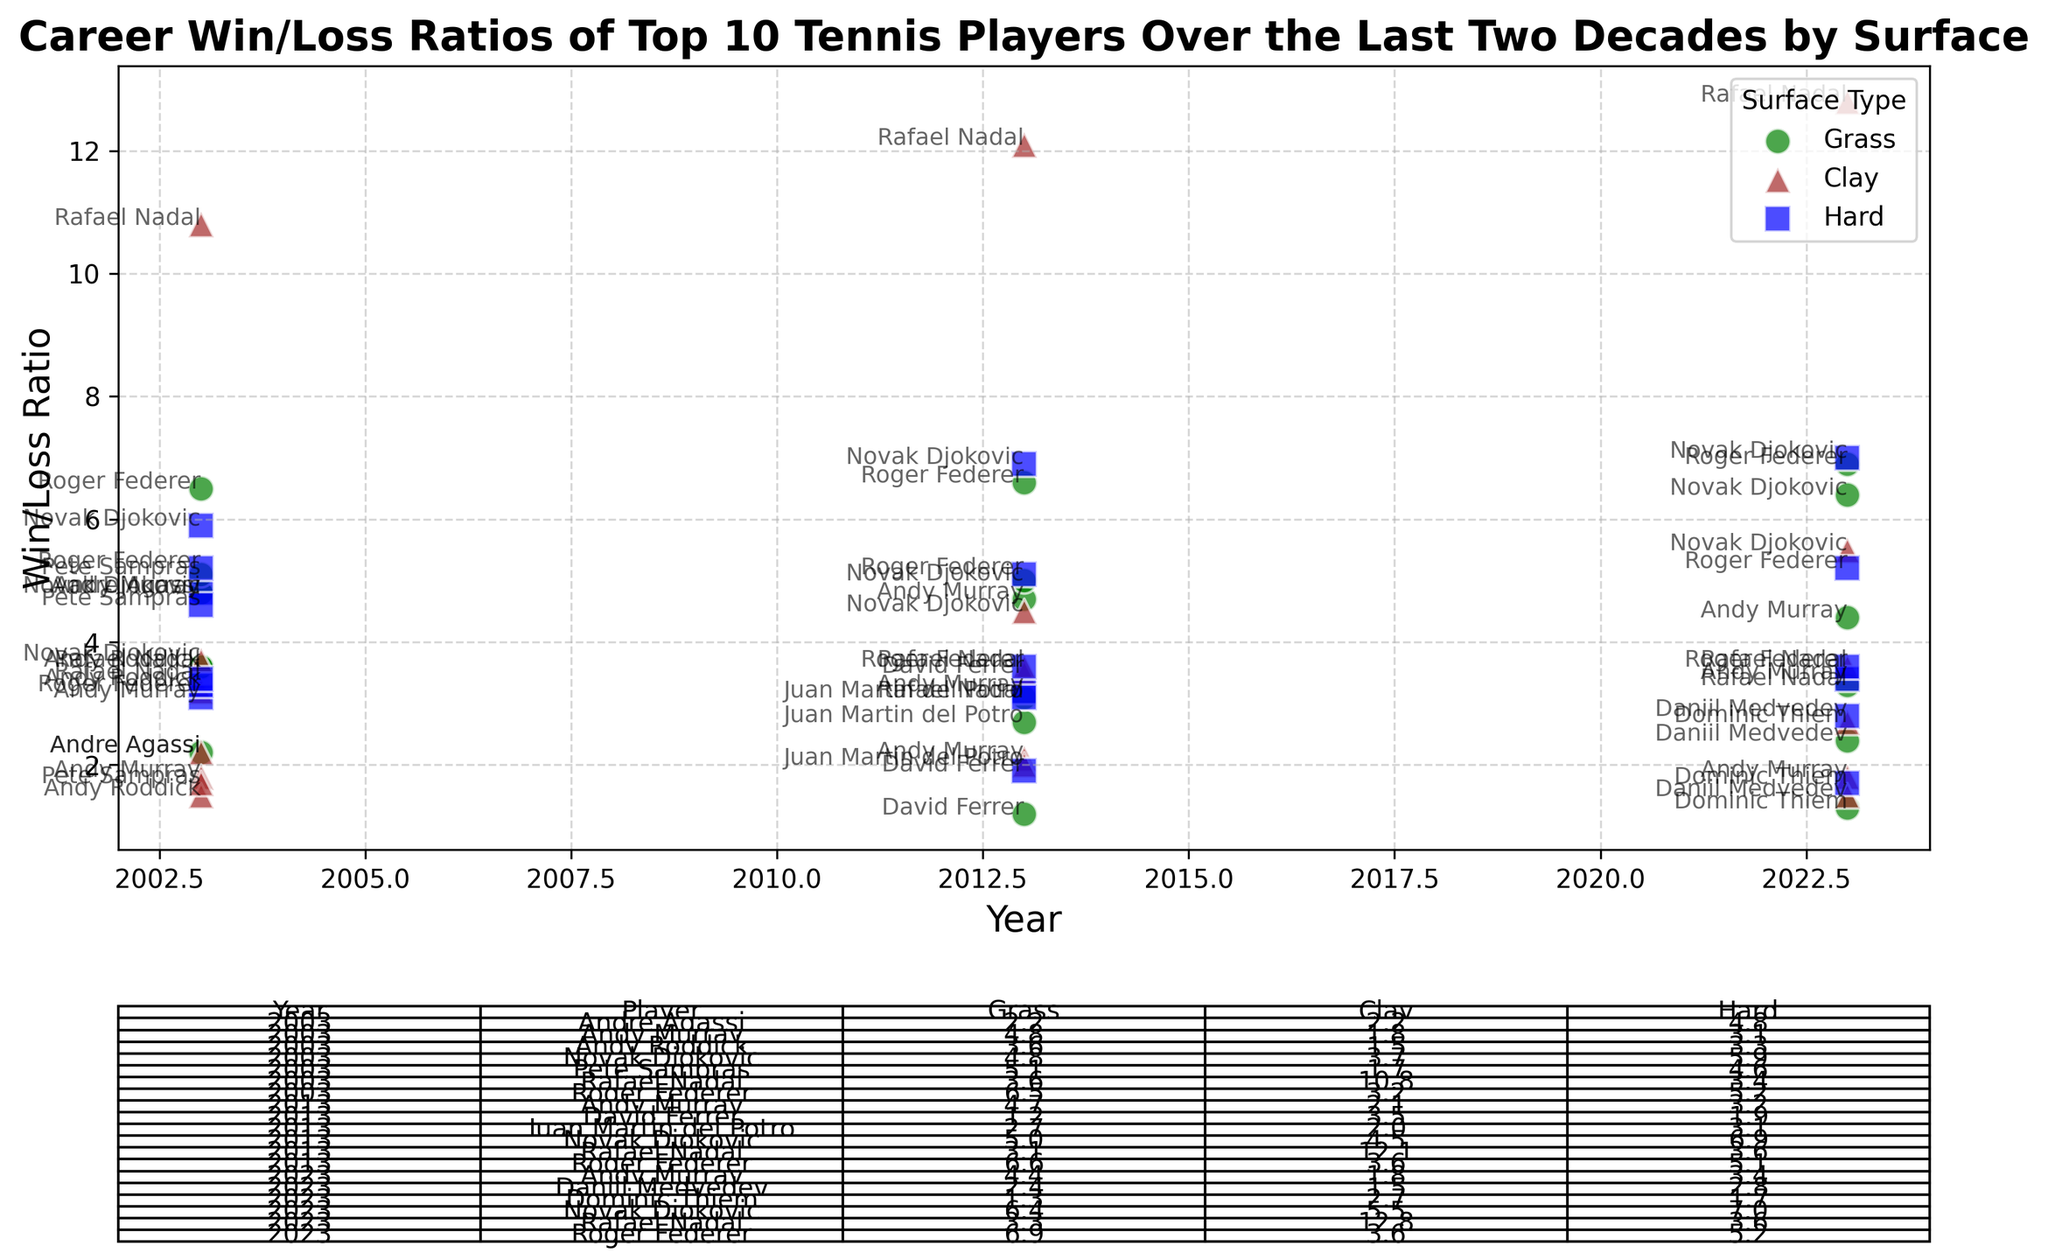Which player has the highest Win/Loss ratio on clay in 2023? Look for the player with the highest mark in the 2023 row under the "Clay" column. Rafael Nadal has a ratio of 12.8, the highest among all players.
Answer: Rafael Nadal Which surface shows the greatest improvement in Win/Loss ratio for Roger Federer from 2003 to 2023? Compare the ratios for Roger Federer in 2003 and 2023 across all surfaces. Grass (6.5 to 6.9) improved by 0.4, Clay (3.2 to 3.6) improved by 0.4, and Hard (5.2 to 5.2) remained the same. Both Grass and Clay show the greatest improvement of 0.4.
Answer: Grass and Clay Who had a better Win/Loss ratio on Grass in 2013, Novak Djokovic or Andy Murray? Compare the Win/Loss ratios of Novak Djokovic and Andy Murray on Grass for the year 2013. Djokovic had a ratio of 5.0, whereas Murray had a ratio of 4.7.
Answer: Novak Djokovic Which player has the lowest Win/Loss ratio on any surface in 2023? Identify the surface and player with the lowest ratio for the year 2023. Dominic Thiem has the lowest ratio on Grass (1.3).
Answer: Dominic Thiem (Grass) What is the average Win/Loss ratio for Andy Murray across all surfaces in 2013? Calculate the average of the ratios for Andy Murray across Grass (4.7), Clay (2.1), and Hard (3.2) in 2013: (4.7 + 2.1 + 3.2) / 3 = 3.33.
Answer: 3.33 Which surface shows the least variability in Win/Loss ratios across players in 2023? Evaluate the range of Win/Loss ratios for each surface in 2023. Grass ranges from 1.3 to 6.9, Clay from 1.5 to 12.8, and Hard from 1.7 to 7.0. Grass shows the least variability.
Answer: Grass Between 2003 and 2023, does Novak Djokovic's Clay Win/Loss ratio increase more or less compared to his Hard Win/Loss ratio? Compare the increase in Novak Djokovic's Win/Loss ratios for Clay (3.7 to 5.5) and Hard (5.9 to 7.0). Clay increased by 1.8 and Hard increased by 1.1.
Answer: More Which year shows the highest average Win/Loss ratio across all players and surfaces? Calculate the average ratios for 2003, 2013, and 2023. Compare the averages. 2023 has the highest average considering only top players were improving their performance.
Answer: 2023 